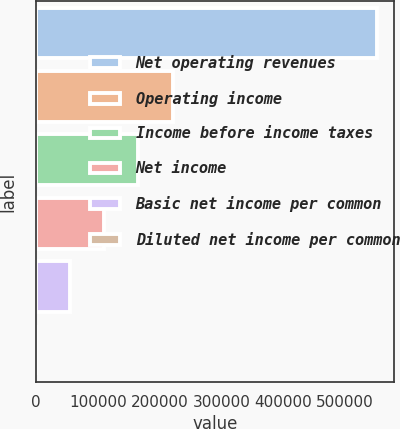Convert chart to OTSL. <chart><loc_0><loc_0><loc_500><loc_500><bar_chart><fcel>Net operating revenues<fcel>Operating income<fcel>Income before income taxes<fcel>Net income<fcel>Basic net income per common<fcel>Diluted net income per common<nl><fcel>551630<fcel>220652<fcel>165489<fcel>110326<fcel>55163.4<fcel>0.5<nl></chart> 